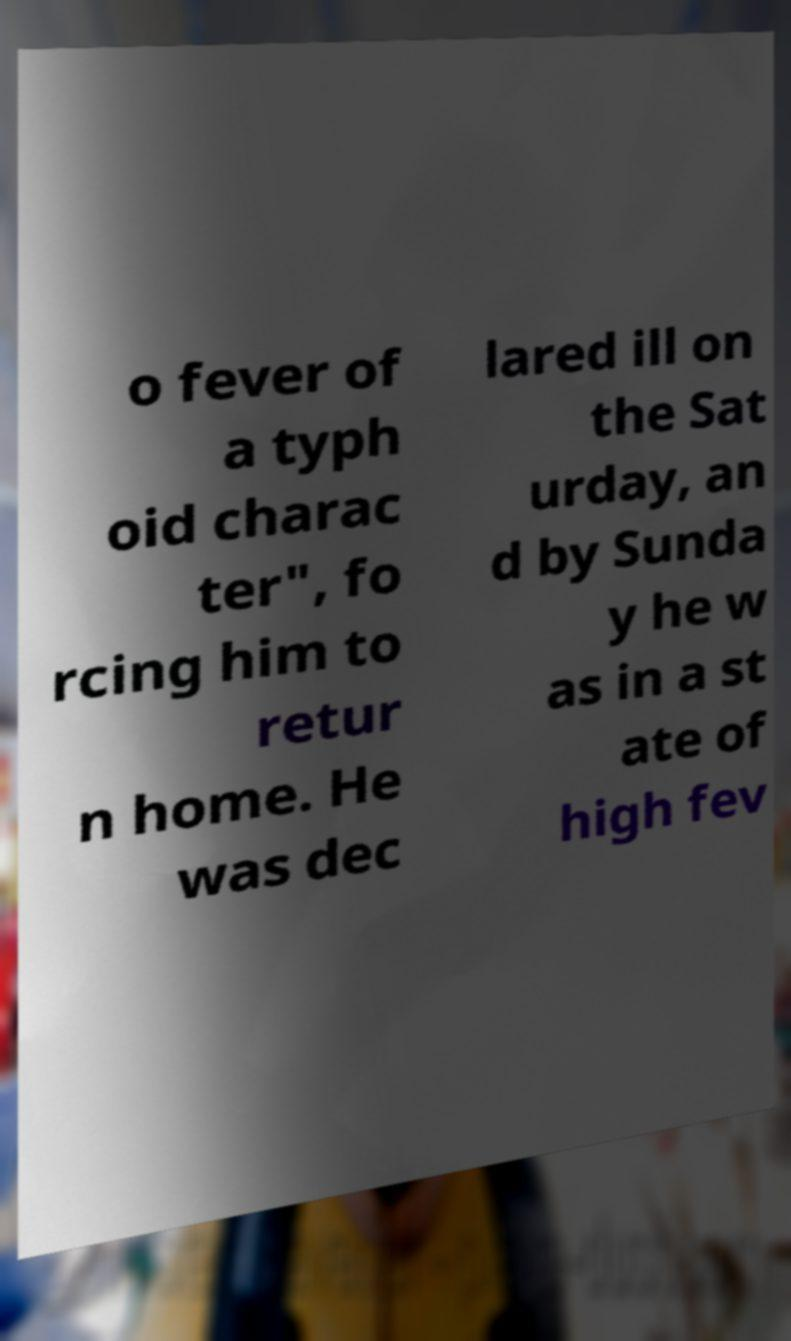There's text embedded in this image that I need extracted. Can you transcribe it verbatim? o fever of a typh oid charac ter", fo rcing him to retur n home. He was dec lared ill on the Sat urday, an d by Sunda y he w as in a st ate of high fev 